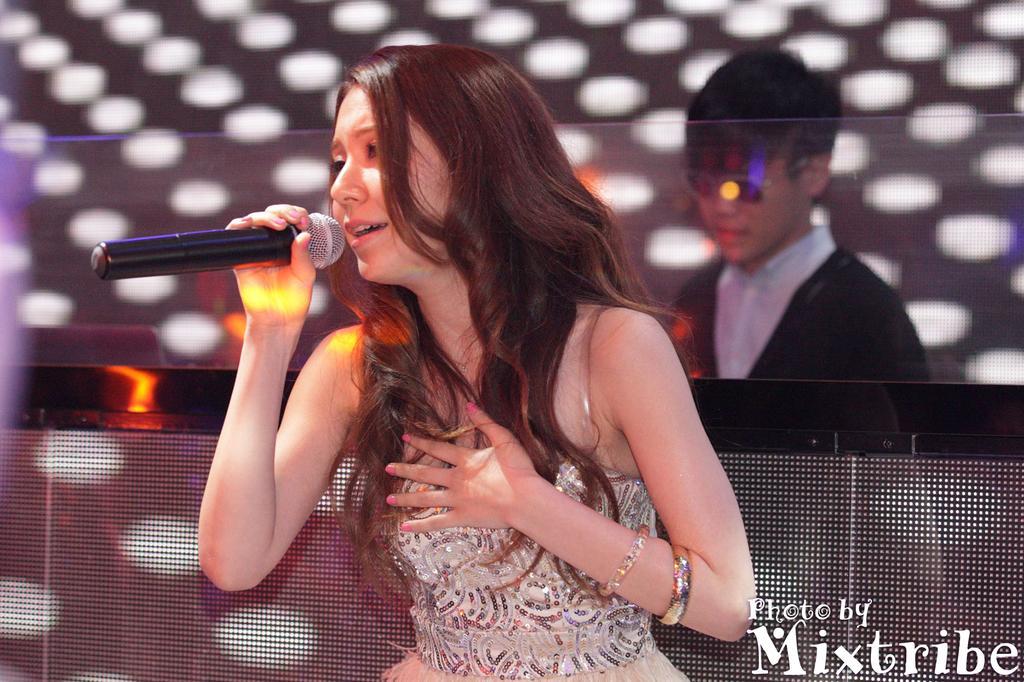In one or two sentences, can you explain what this image depicts? In this image, There is a woman sitting in the middle and she is holding a microphone which is in black color, In the background there is a boy standing. 